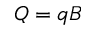Convert formula to latex. <formula><loc_0><loc_0><loc_500><loc_500>Q = q B</formula> 